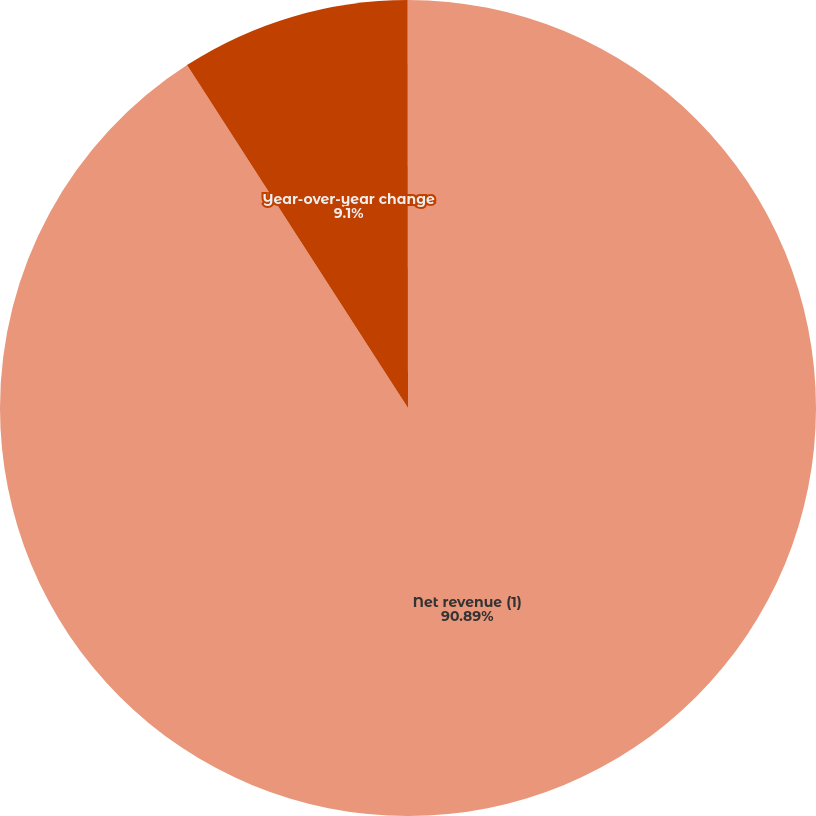Convert chart. <chart><loc_0><loc_0><loc_500><loc_500><pie_chart><fcel>Net revenue (1)<fcel>Year-over-year change<fcel>Earnings (loss) from<nl><fcel>90.89%<fcel>9.1%<fcel>0.01%<nl></chart> 